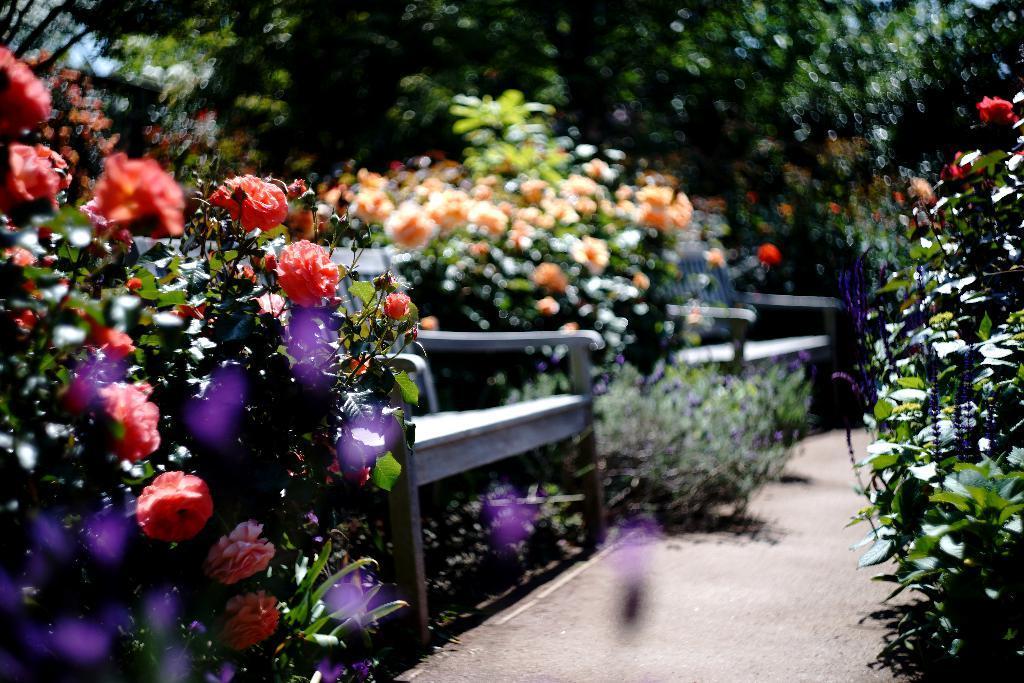In one or two sentences, can you explain what this image depicts? In this image we can see plants, flowers and trees. At the bottom there are benches and we can see a walkway. 